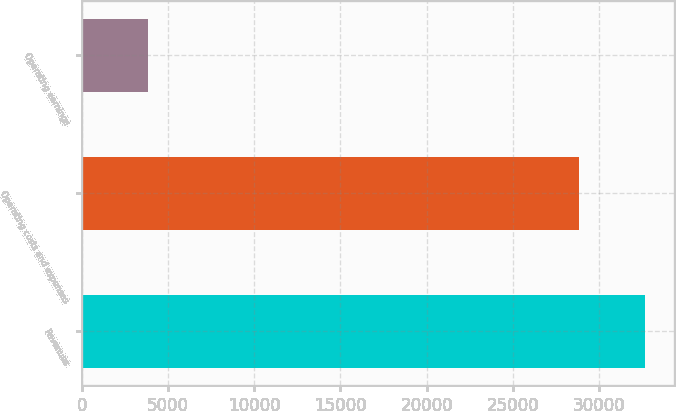<chart> <loc_0><loc_0><loc_500><loc_500><bar_chart><fcel>Revenues<fcel>Operating costs and expenses<fcel>Operating earnings<nl><fcel>32677<fcel>28851<fcel>3826<nl></chart> 